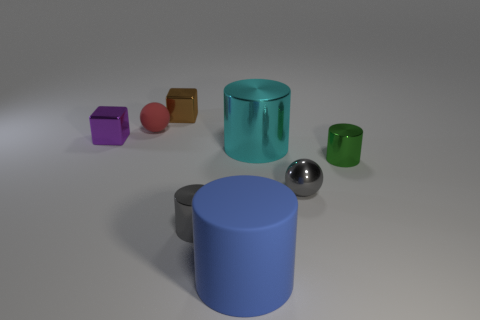What is the material of the ball that is on the left side of the gray object that is on the left side of the large blue matte thing? The ball in question appears to be made of a polished metal, reflecting the environment with a mirror-like surface, as opposed to rubber, which would have a matte and less reflective finish. 